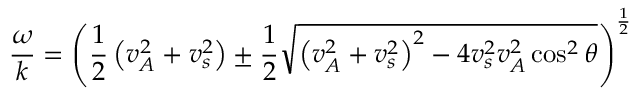Convert formula to latex. <formula><loc_0><loc_0><loc_500><loc_500>{ \frac { \omega } { k } } = \left ( { \frac { 1 } { 2 } } \left ( v _ { A } ^ { 2 } + v _ { s } ^ { 2 } \right ) \pm { \frac { 1 } { 2 } } { \sqrt { \left ( v _ { A } ^ { 2 } + v _ { s } ^ { 2 } \right ) ^ { 2 } - 4 v _ { s } ^ { 2 } v _ { A } ^ { 2 } \cos ^ { 2 } \theta } } \right ) ^ { \frac { 1 } { 2 } }</formula> 